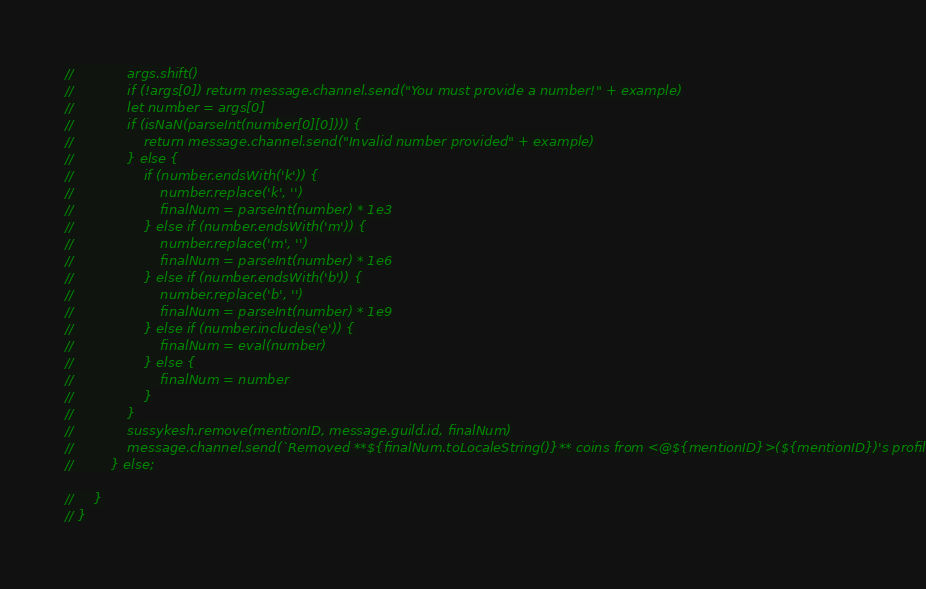Convert code to text. <code><loc_0><loc_0><loc_500><loc_500><_JavaScript_>//             args.shift()
//             if (!args[0]) return message.channel.send("You must provide a number!" + example)
//             let number = args[0]
//             if (isNaN(parseInt(number[0][0]))) {
//                 return message.channel.send("Invalid number provided" + example)
//             } else {
//                 if (number.endsWith('k')) {
//                     number.replace('k', '')
//                     finalNum = parseInt(number) * 1e3
//                 } else if (number.endsWith('m')) {
//                     number.replace('m', '')
//                     finalNum = parseInt(number) * 1e6
//                 } else if (number.endsWith('b')) {
//                     number.replace('b', '')
//                     finalNum = parseInt(number) * 1e9
//                 } else if (number.includes('e')) {
//                     finalNum = eval(number)
//                 } else {
//                     finalNum = number
//                 }
//             }
//             sussykesh.remove(mentionID, message.guild.id, finalNum)
//             message.channel.send(`Removed **${finalNum.toLocaleString()}** coins from <@${mentionID}>(${mentionID})'s profile!`)
//         } else;

//     }
// }
</code> 